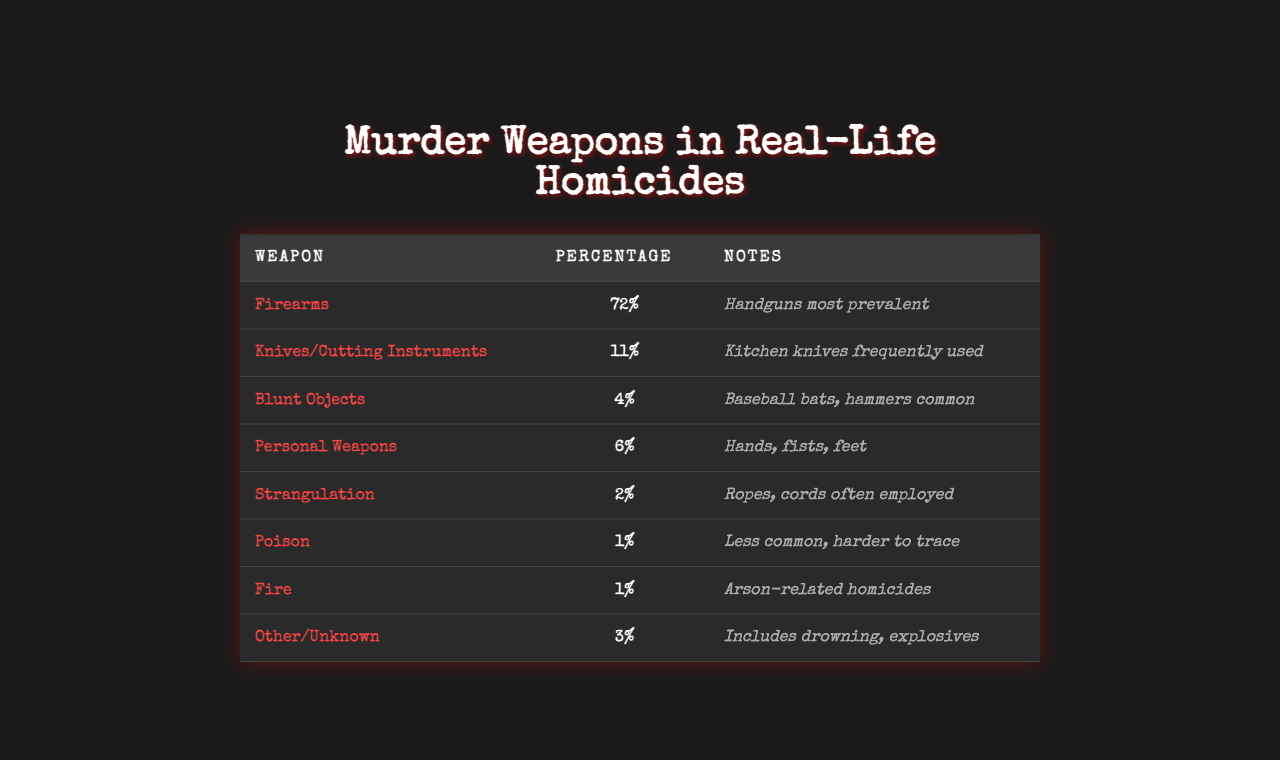What is the most common murder weapon in real-life homicides? The table shows that the weapon categorized as "Firearms" has the highest percentage at 72%.
Answer: Firearms What percentage of homicides are committed using knives or cutting instruments? According to the table, knives or cutting instruments account for 11% of homicides.
Answer: 11% Is strangulation more common than the use of poison in homicides? The table indicates that strangulation accounts for 2%, whereas poison accounts for only 1%. Therefore, strangulation is more common.
Answer: Yes What percentage of homicides involves blunt objects? The table indicates blunt objects are involved in 4% of homicides.
Answer: 4% How many murder weapon categories are listed in the table? The table has eight different categories of murder weapons listed.
Answer: 8 What percentage of homicides involve personal weapons compared to firearms? Personal weapons account for 6%, while firearms account for 72%. The difference between them is 72% - 6% = 66%.
Answer: 66% What is the combined percentage of homicides involving fire and poison? Fire accounts for 1% and poison for 1%, so their combined percentage is 1% + 1% = 2%.
Answer: 2% Which weapon is less common: strangulation or personal weapons? Strangulation is at 2% while personal weapons are at 6%, making strangulation less common.
Answer: Strangulation If the weapons in the 'Other/Unknown' category were specifically excluded, what would be the total percentage of homicides accounted for by the other weapons? Excluding the 'Other/Unknown' category (3%), we sum the other percentages: 72% + 11% + 4% + 6% + 2% + 1% + 1% = 97%.
Answer: 97% What percentage of homicides could be considered as "not using firearms"? Firearms account for 72%, so the percentage that does not use firearms is 100% - 72% = 28%.
Answer: 28% 